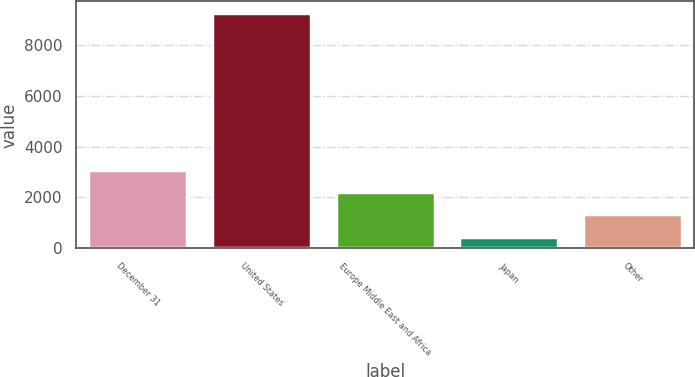Convert chart. <chart><loc_0><loc_0><loc_500><loc_500><bar_chart><fcel>December 31<fcel>United States<fcel>Europe Middle East and Africa<fcel>Japan<fcel>Other<nl><fcel>3096.03<fcel>9249.1<fcel>2217.02<fcel>459<fcel>1338.01<nl></chart> 